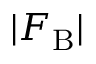Convert formula to latex. <formula><loc_0><loc_0><loc_500><loc_500>| F _ { B } |</formula> 